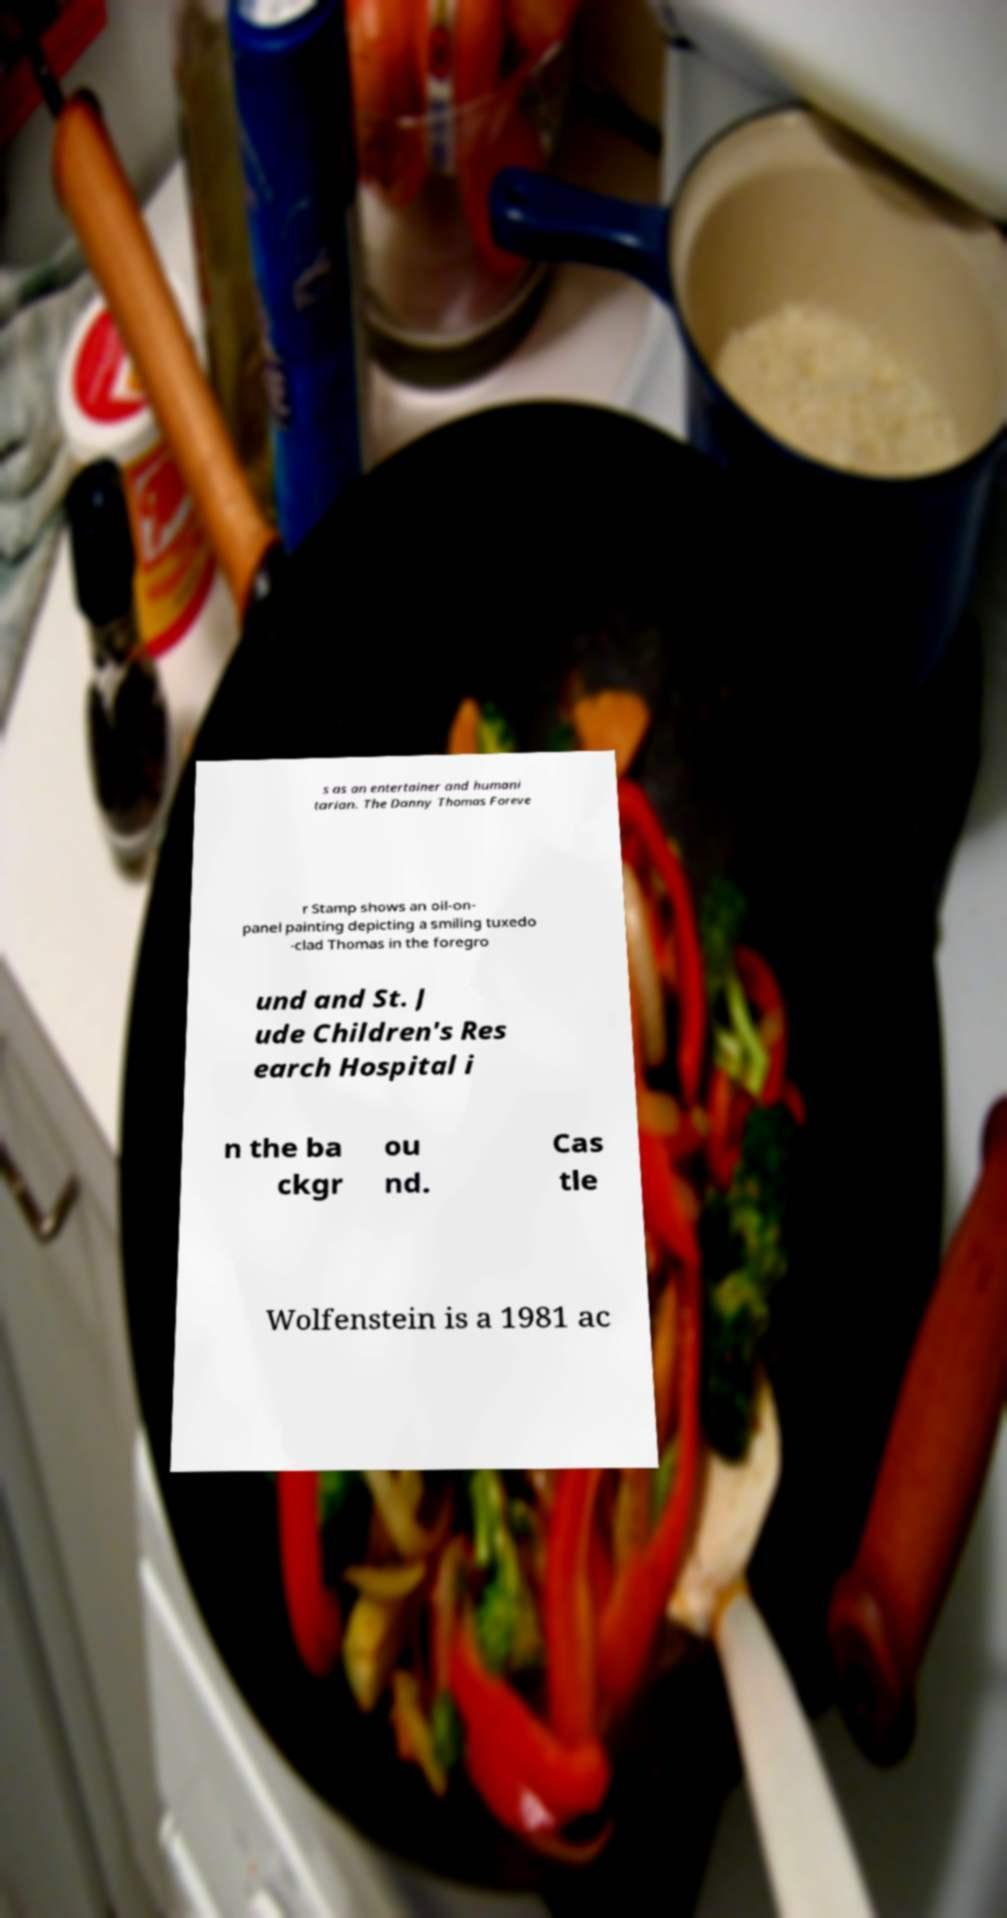Could you assist in decoding the text presented in this image and type it out clearly? s as an entertainer and humani tarian. The Danny Thomas Foreve r Stamp shows an oil-on- panel painting depicting a smiling tuxedo -clad Thomas in the foregro und and St. J ude Children's Res earch Hospital i n the ba ckgr ou nd. Cas tle Wolfenstein is a 1981 ac 